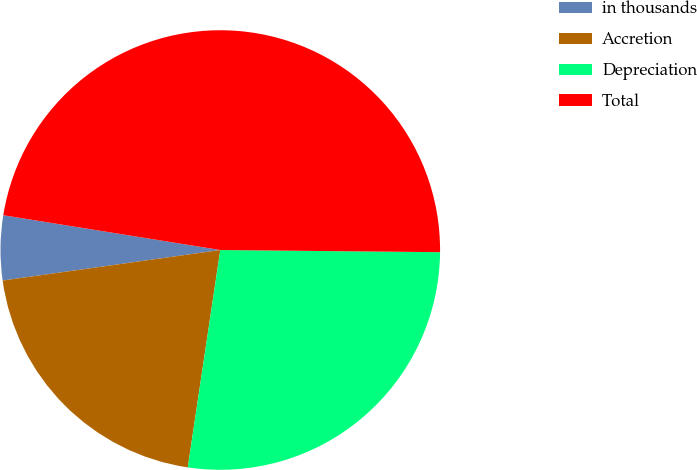Convert chart to OTSL. <chart><loc_0><loc_0><loc_500><loc_500><pie_chart><fcel>in thousands<fcel>Accretion<fcel>Depreciation<fcel>Total<nl><fcel>4.75%<fcel>20.42%<fcel>27.21%<fcel>47.63%<nl></chart> 